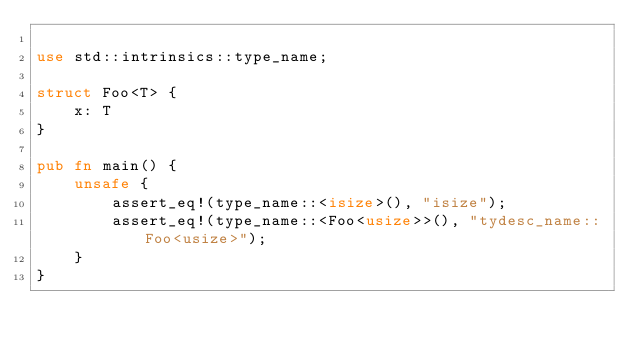Convert code to text. <code><loc_0><loc_0><loc_500><loc_500><_Rust_>
use std::intrinsics::type_name;

struct Foo<T> {
    x: T
}

pub fn main() {
    unsafe {
        assert_eq!(type_name::<isize>(), "isize");
        assert_eq!(type_name::<Foo<usize>>(), "tydesc_name::Foo<usize>");
    }
}
</code> 